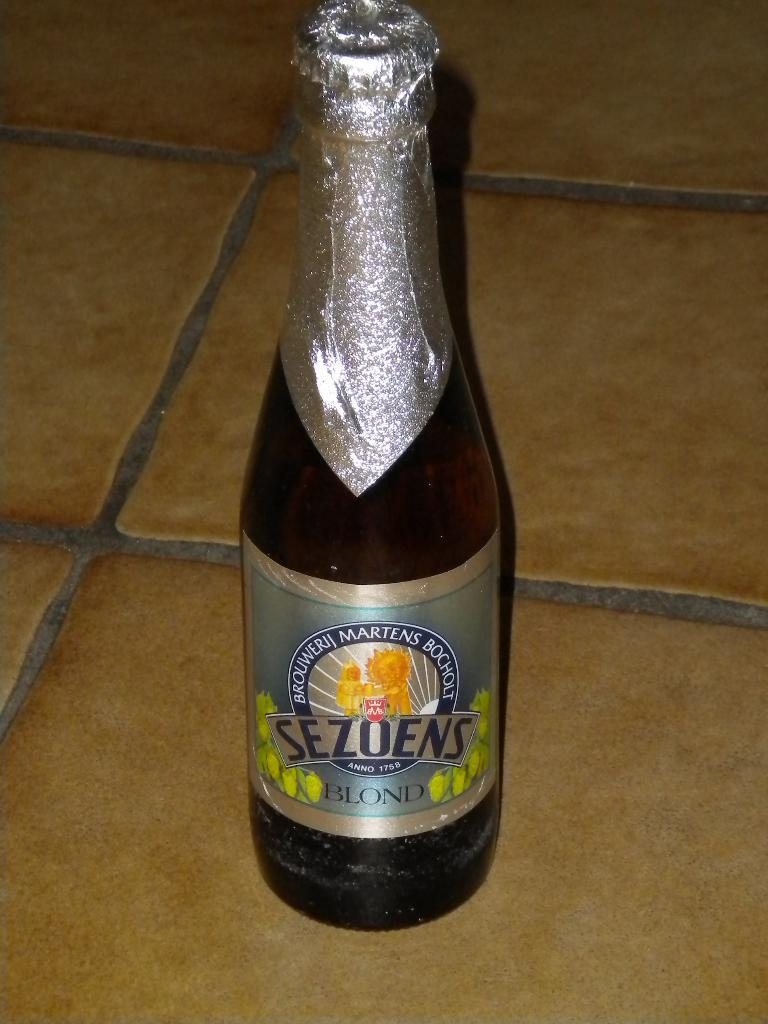<image>
Offer a succinct explanation of the picture presented. A bottle of something covered in foil with the name SEZOENS BLOND. 